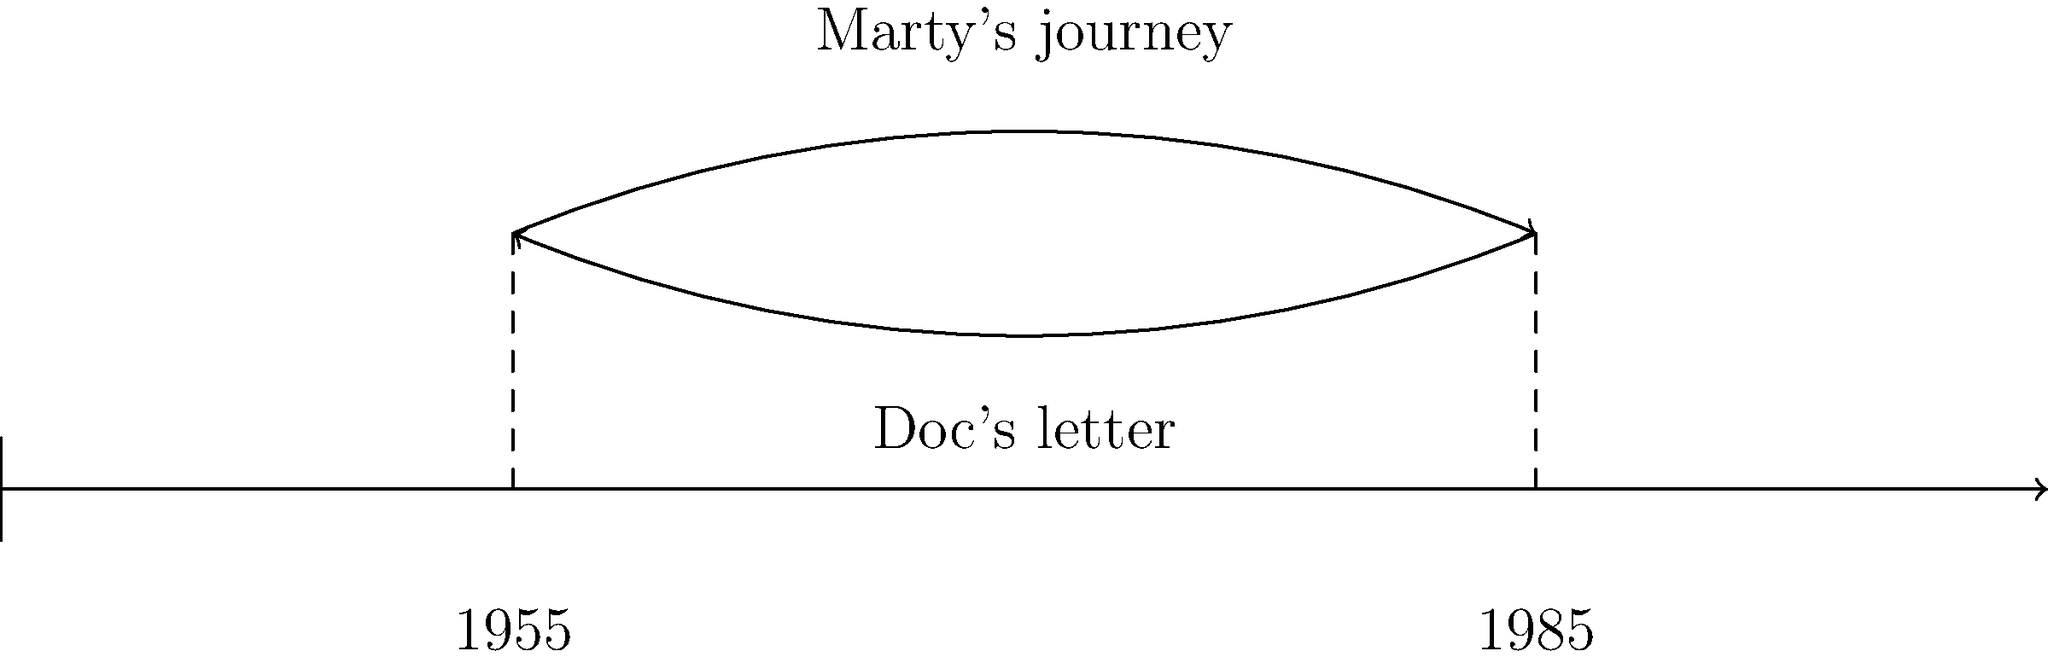Analyze the timeline diagram of "Back to the Future." How does this non-linear narrative structure contribute to the film's exploration of causality and the butterfly effect? Provide specific examples from the movie to support your analysis. To answer this question, let's break down the timeline diagram and its implications:

1. The diagram shows two main time periods: 1955 and 1985.

2. Marty's journey is represented by the upper arc, moving from 1985 to 1955 and back to 1985.

3. Doc's letter is shown by the lower arc, moving backwards from 1985 to 1955.

4. This non-linear structure contributes to the film's exploration of causality and the butterfly effect in several ways:

   a) Cause and Effect: Marty's actions in 1955 directly impact his present (1985). For example, his interference with his parents' meeting changes his family's future.

   b) Paradoxes: The film explores temporal paradoxes, such as Marty being responsible for his own existence by ensuring his parents fall in love.

   c) Butterfly Effect: Small changes in the past (like Marty saving his father from being hit by a car) lead to significant alterations in the future.

   d) Interconnectedness: The diagram shows how events in different time periods are interconnected, emphasizing the delicate balance of time.

   e) Dramatic Irony: The audience knows information that characters in certain time periods don't, creating tension and humor.

5. Specific examples from the movie:
   - Marty teaching his father confidence in 1955 leads to a more successful family in 1985.
   - The letter from Doc in 1985 saves his life in 1955, creating a closed time loop.
   - Marty's interference with his parents' meeting threatens his own existence, demonstrating the fragility of causality.

This non-linear structure allows the film to explore complex themes of time travel, causality, and personal responsibility in a visually engaging and narratively compelling manner.
Answer: The non-linear narrative enhances exploration of causality and the butterfly effect by visually representing interconnected events across time periods, demonstrating how actions in the past directly impact the future. 